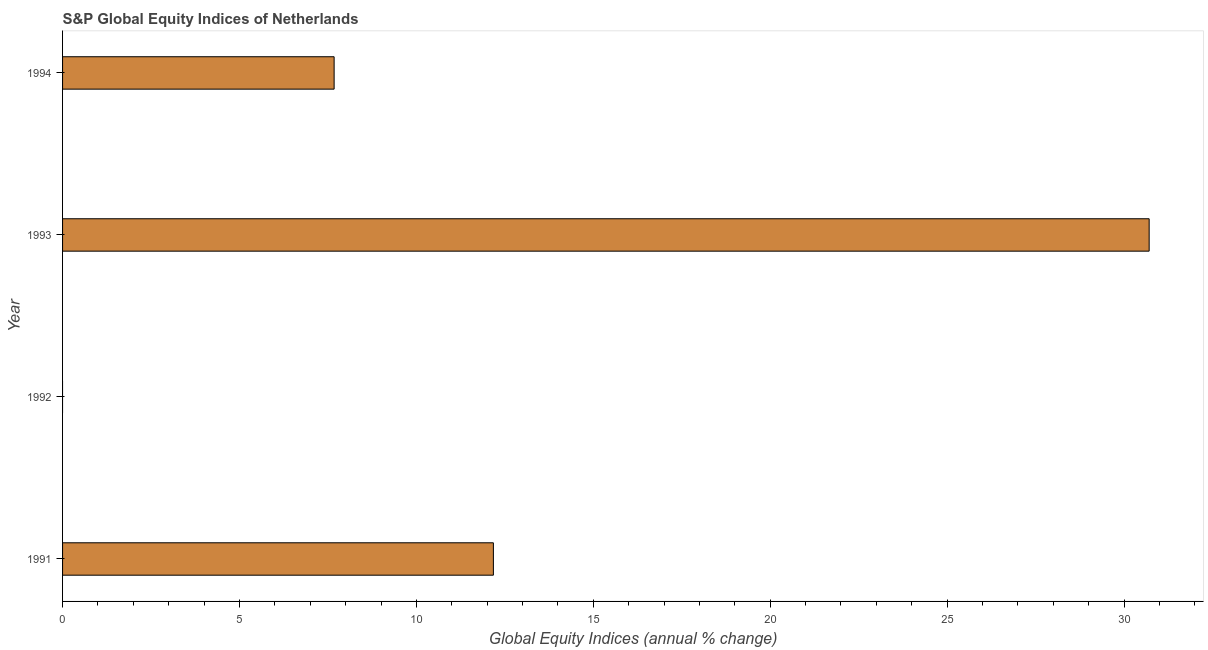Does the graph contain any zero values?
Offer a very short reply. Yes. Does the graph contain grids?
Give a very brief answer. No. What is the title of the graph?
Give a very brief answer. S&P Global Equity Indices of Netherlands. What is the label or title of the X-axis?
Your answer should be compact. Global Equity Indices (annual % change). What is the s&p global equity indices in 1994?
Give a very brief answer. 7.68. Across all years, what is the maximum s&p global equity indices?
Your answer should be compact. 30.71. In which year was the s&p global equity indices maximum?
Give a very brief answer. 1993. What is the sum of the s&p global equity indices?
Make the answer very short. 50.56. What is the difference between the s&p global equity indices in 1991 and 1993?
Your answer should be compact. -18.53. What is the average s&p global equity indices per year?
Ensure brevity in your answer.  12.64. What is the median s&p global equity indices?
Offer a very short reply. 9.93. What is the ratio of the s&p global equity indices in 1991 to that in 1994?
Your answer should be very brief. 1.59. Is the difference between the s&p global equity indices in 1993 and 1994 greater than the difference between any two years?
Provide a succinct answer. No. What is the difference between the highest and the second highest s&p global equity indices?
Ensure brevity in your answer.  18.53. Is the sum of the s&p global equity indices in 1991 and 1993 greater than the maximum s&p global equity indices across all years?
Make the answer very short. Yes. What is the difference between the highest and the lowest s&p global equity indices?
Your answer should be compact. 30.71. In how many years, is the s&p global equity indices greater than the average s&p global equity indices taken over all years?
Provide a short and direct response. 1. Are the values on the major ticks of X-axis written in scientific E-notation?
Make the answer very short. No. What is the Global Equity Indices (annual % change) of 1991?
Ensure brevity in your answer.  12.18. What is the Global Equity Indices (annual % change) in 1992?
Ensure brevity in your answer.  0. What is the Global Equity Indices (annual % change) in 1993?
Your response must be concise. 30.71. What is the Global Equity Indices (annual % change) in 1994?
Your answer should be very brief. 7.68. What is the difference between the Global Equity Indices (annual % change) in 1991 and 1993?
Provide a succinct answer. -18.53. What is the difference between the Global Equity Indices (annual % change) in 1991 and 1994?
Offer a very short reply. 4.5. What is the difference between the Global Equity Indices (annual % change) in 1993 and 1994?
Ensure brevity in your answer.  23.04. What is the ratio of the Global Equity Indices (annual % change) in 1991 to that in 1993?
Offer a very short reply. 0.4. What is the ratio of the Global Equity Indices (annual % change) in 1991 to that in 1994?
Give a very brief answer. 1.59. What is the ratio of the Global Equity Indices (annual % change) in 1993 to that in 1994?
Your answer should be compact. 4. 